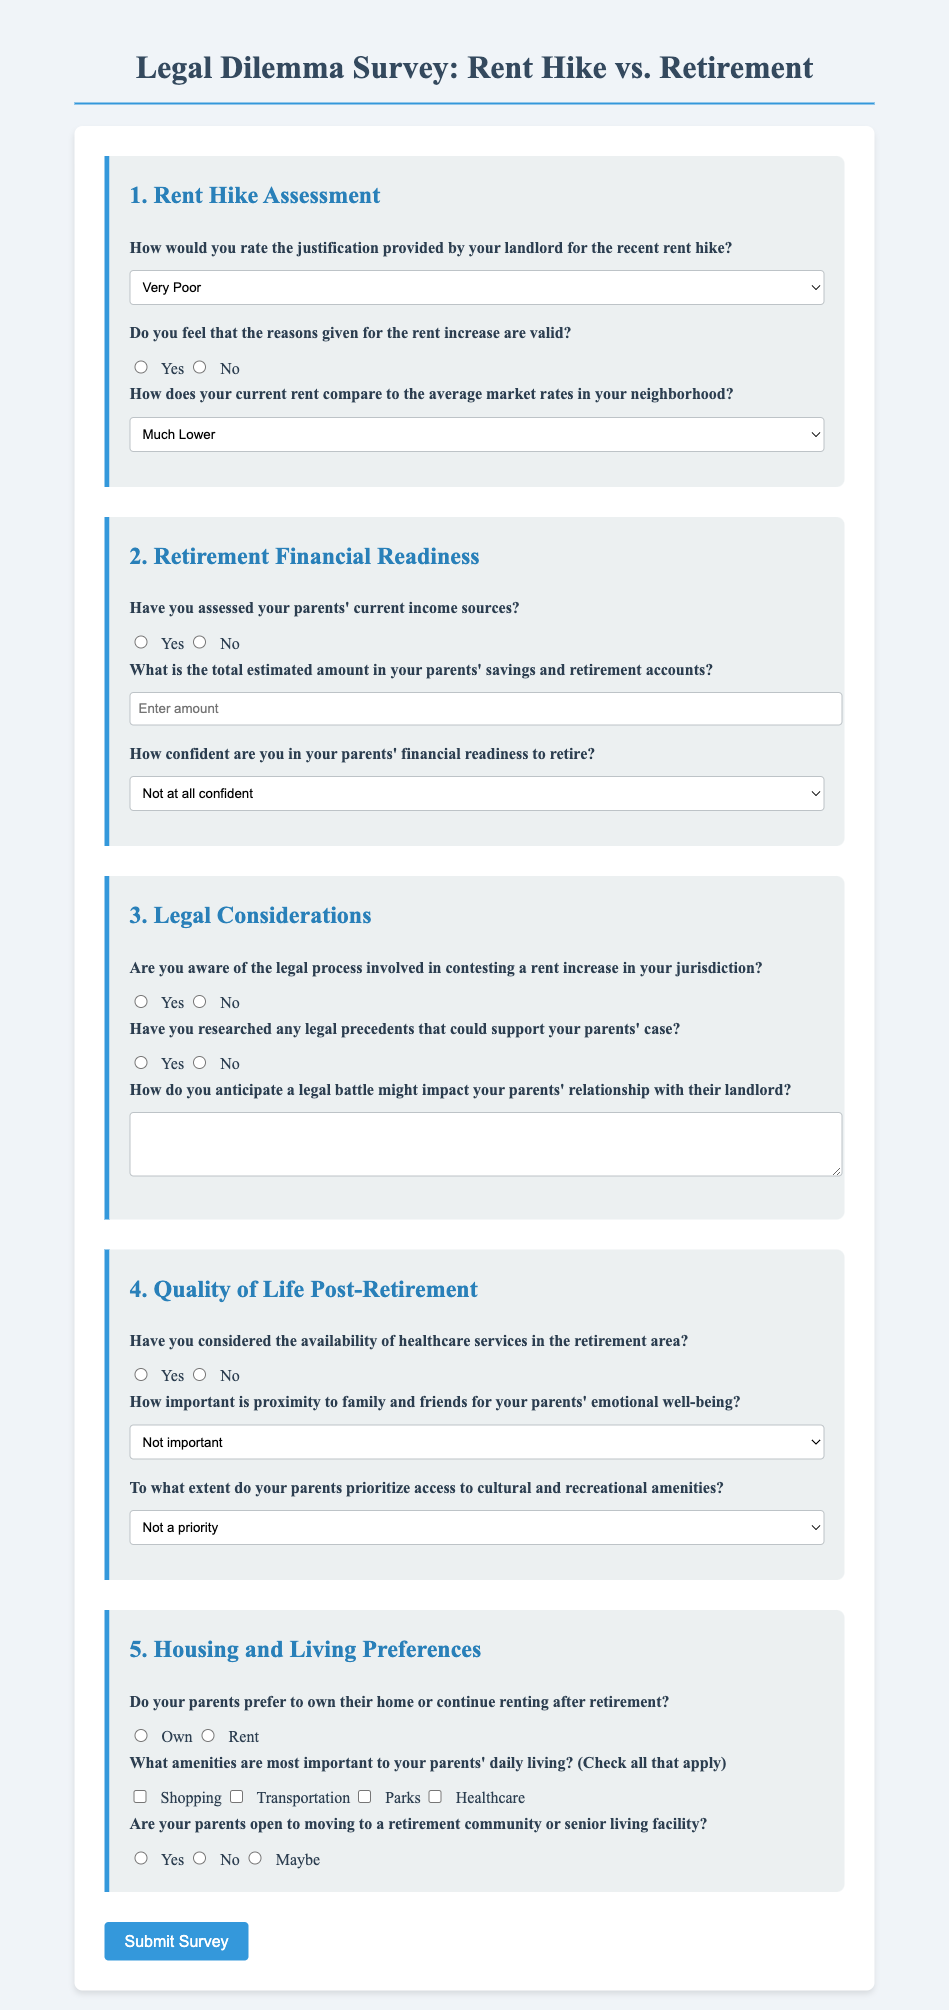What is the title of the survey? The title of the survey is displayed prominently at the top of the document.
Answer: Legal Dilemma Survey: Rent Hike vs. Retirement How many main sections are there in the survey? The survey contains multiple sections, each addressing different topics related to the legal and financial dilemmas.
Answer: Five What option represents the lowest confidence level in the financial readiness of parents to retire? The survey provides multiple options for assessing confidence levels, with specific response choices.
Answer: Not at all confident Which amenities are checked in the amenities section? The document lists several potential amenities to choose from in the housing preferences.
Answer: Shopping, Transportation, Parks, Healthcare What is the purpose of the housing preference question? This question aims to gather information about the preferences of parents regarding home ownership versus renting post-retirement.
Answer: To understand parental housing preferences What are the possible answers for the importance of proximity to family and friends? There are multiple levels of importance listed for proximity to family and friends in the quality of life section.
Answer: Not important, Somewhat important, Important, Very important, Crucial What kind of impact is anticipated from a legal battle? This question prompts respondents to think about the potential consequences of legal action on relationships with landlords.
Answer: Impact on relationship with landlord (open-ended) How are the select options styled in the document? The select options are styled consistently throughout the document with a defined width and padding.
Answer: Full-width with padding Is there a question assessing the understanding of tenant rights? Yes, the survey includes a question that relates to awareness of legal processes that inform tenant rights.
Answer: Yes 